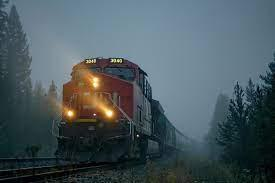How many unicorns are there in the image? 0 